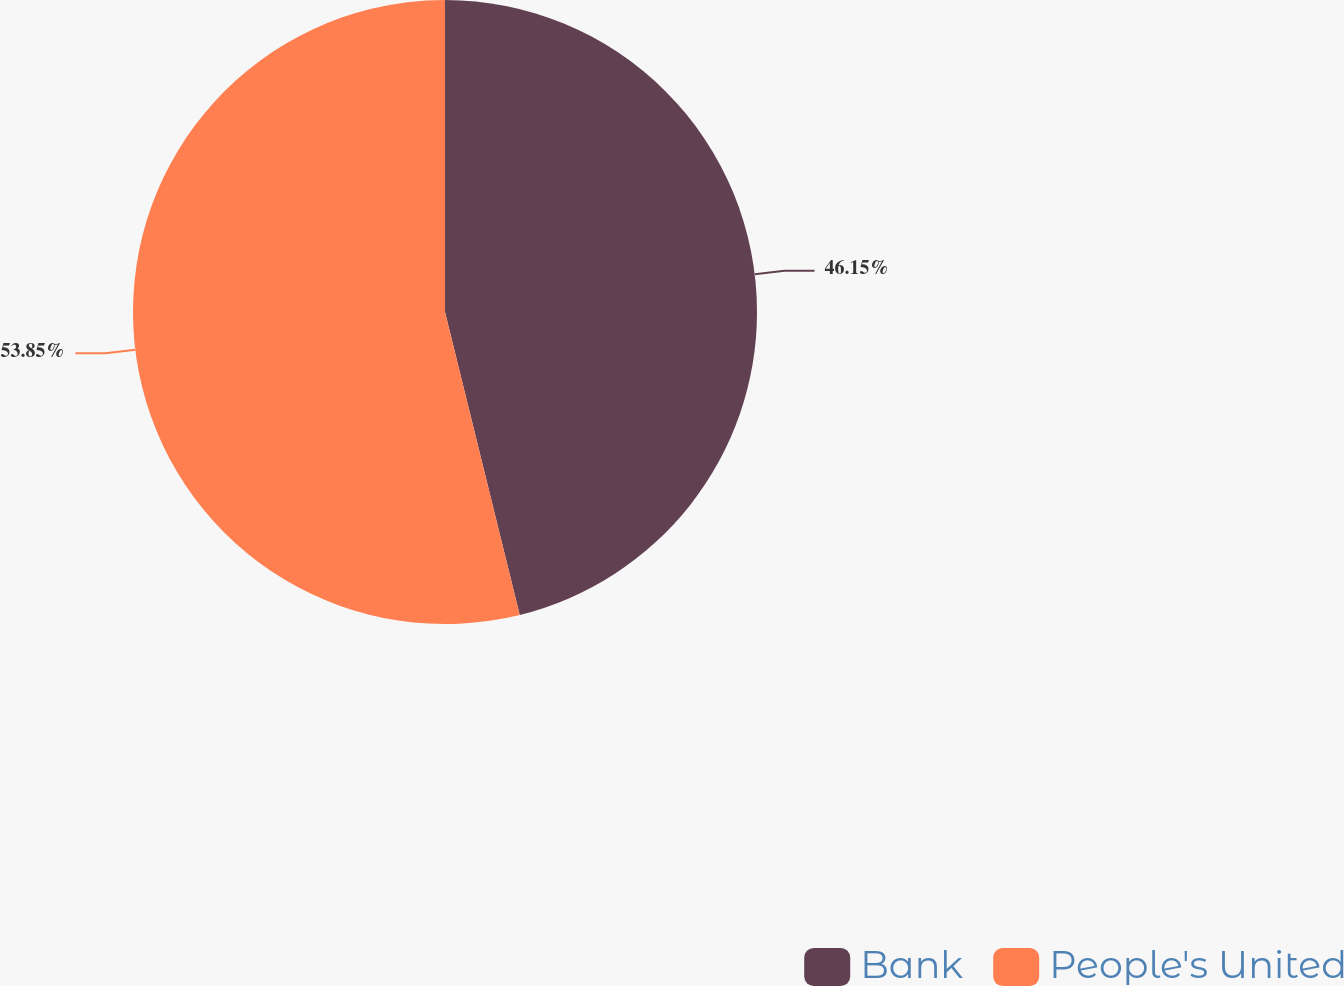Convert chart to OTSL. <chart><loc_0><loc_0><loc_500><loc_500><pie_chart><fcel>Bank<fcel>People's United<nl><fcel>46.15%<fcel>53.85%<nl></chart> 